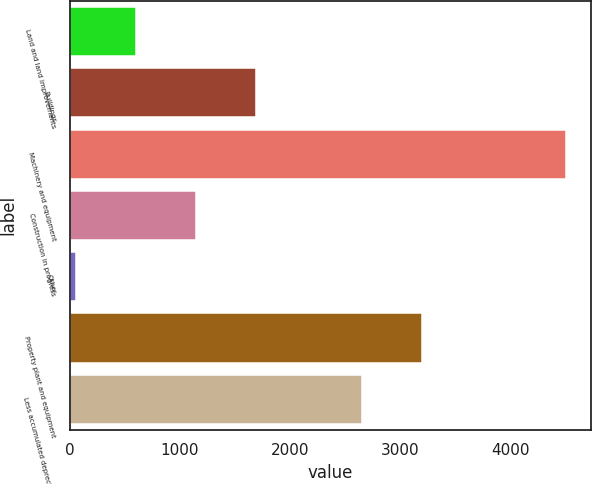<chart> <loc_0><loc_0><loc_500><loc_500><bar_chart><fcel>Land and land improvements<fcel>Buildings<fcel>Machinery and equipment<fcel>Construction in progress<fcel>Other<fcel>Property plant and equipment<fcel>Less accumulated depreciation<nl><fcel>600.59<fcel>1692.77<fcel>4508<fcel>1146.68<fcel>54.5<fcel>3203.89<fcel>2657.8<nl></chart> 